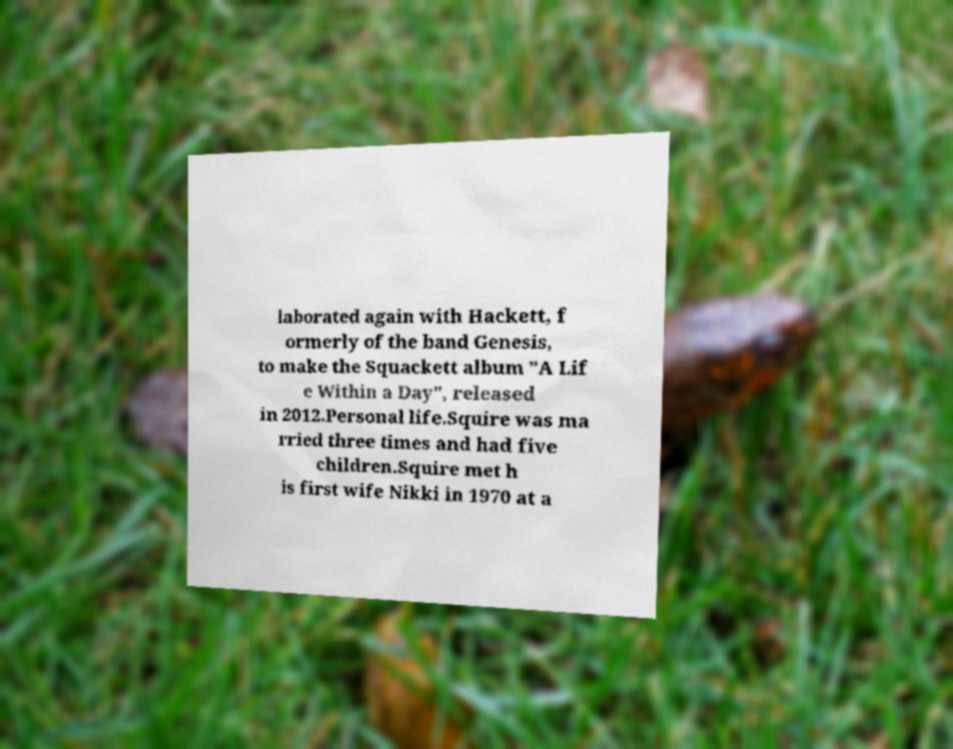There's text embedded in this image that I need extracted. Can you transcribe it verbatim? laborated again with Hackett, f ormerly of the band Genesis, to make the Squackett album "A Lif e Within a Day", released in 2012.Personal life.Squire was ma rried three times and had five children.Squire met h is first wife Nikki in 1970 at a 